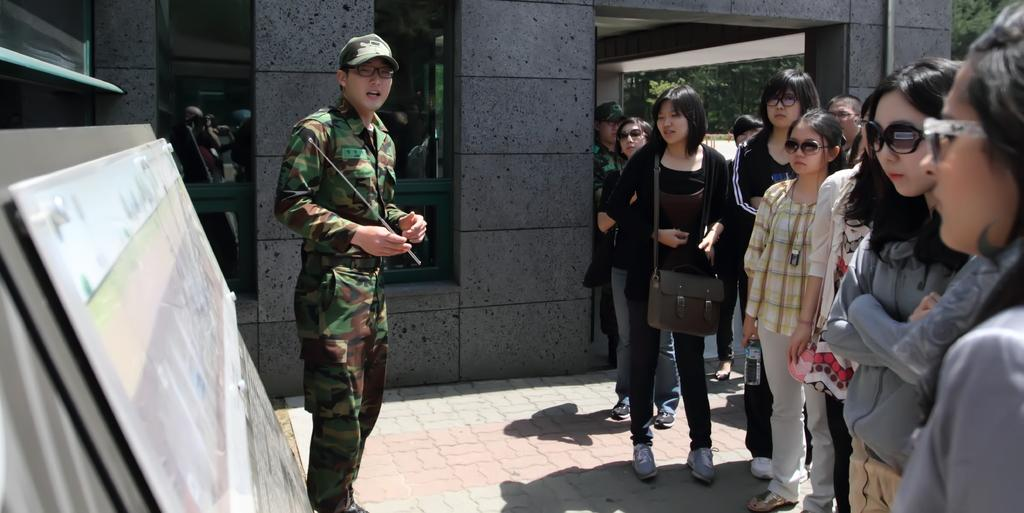How many people are in the image? There is a group of people standing in the image. What is the woman holding in her hand? A woman is holding an object in her hand. What type of structure can be seen in the image? There is a building in the image. What type of vegetation is present in the image? There are trees in the image. What type of locket is the woman wearing on her back in the image? There is no locket visible on the woman's back in the image. How does the group of people move around in the image? The group of people is not moving around in the image; they are standing still. 